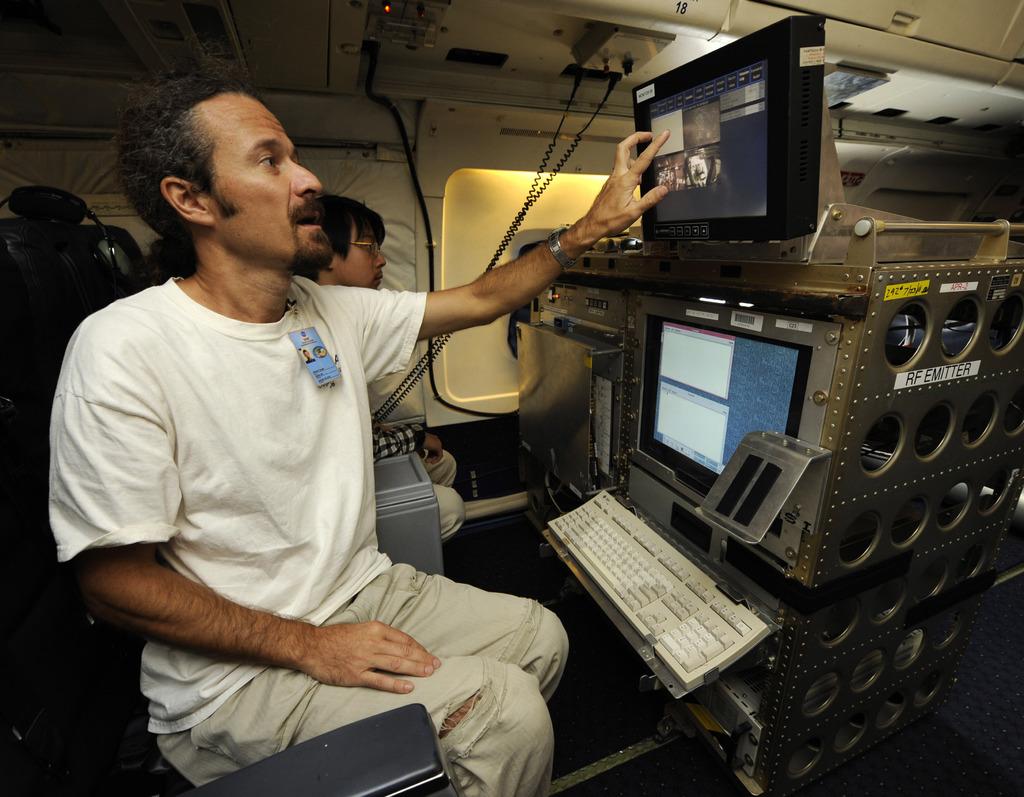What does this machine emit?
Give a very brief answer. Rf. 